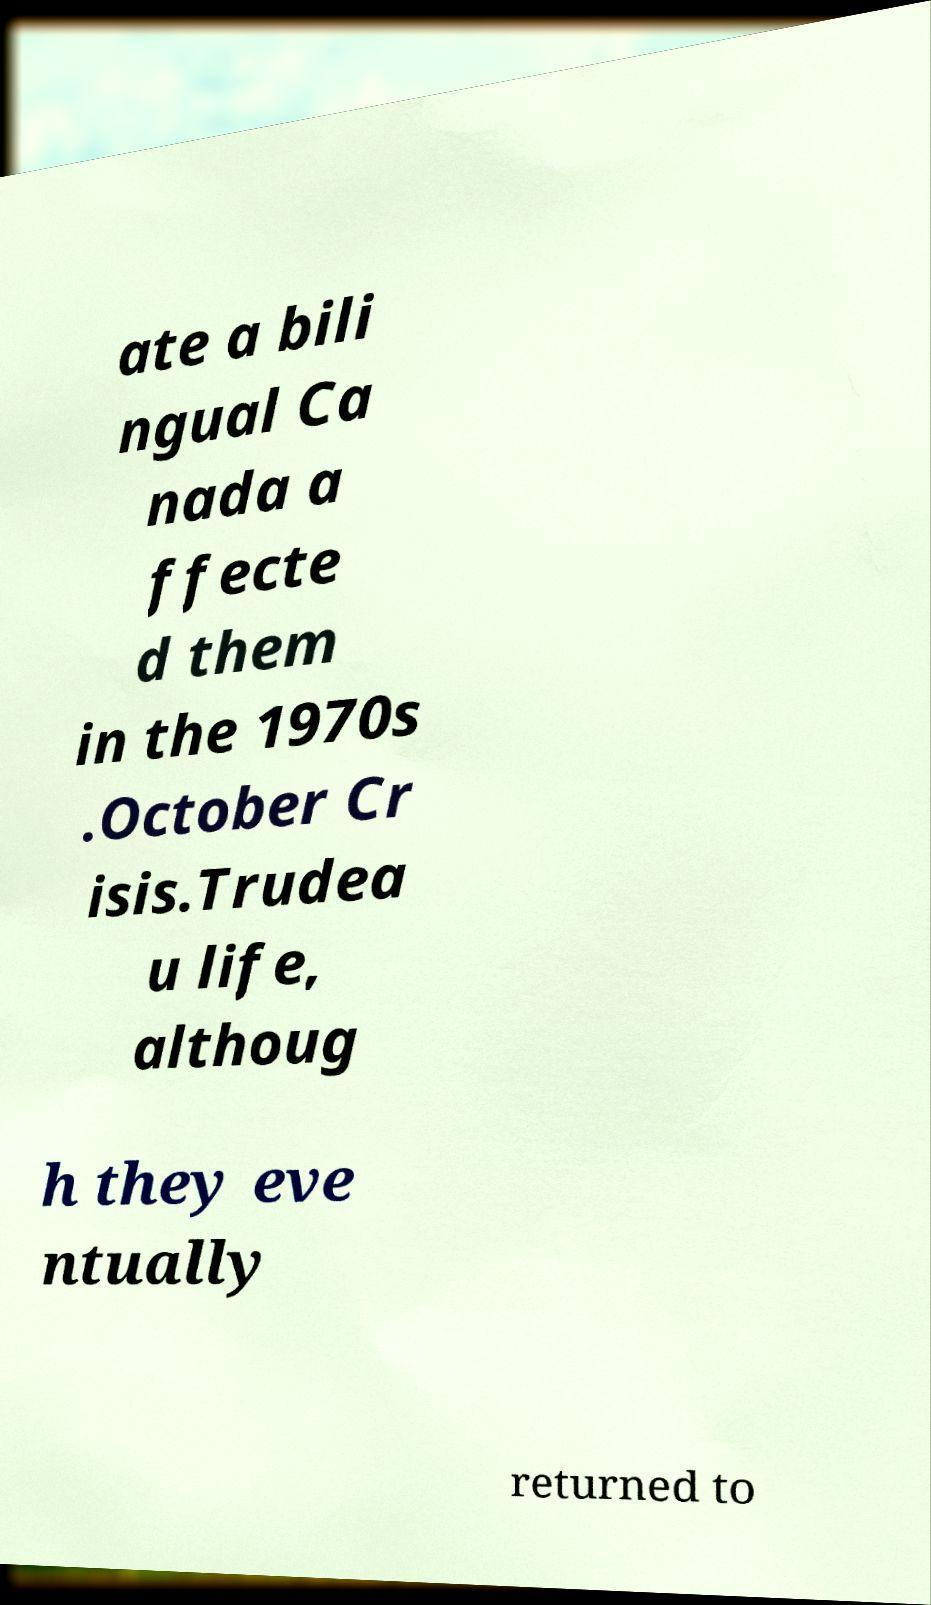Could you assist in decoding the text presented in this image and type it out clearly? ate a bili ngual Ca nada a ffecte d them in the 1970s .October Cr isis.Trudea u life, althoug h they eve ntually returned to 